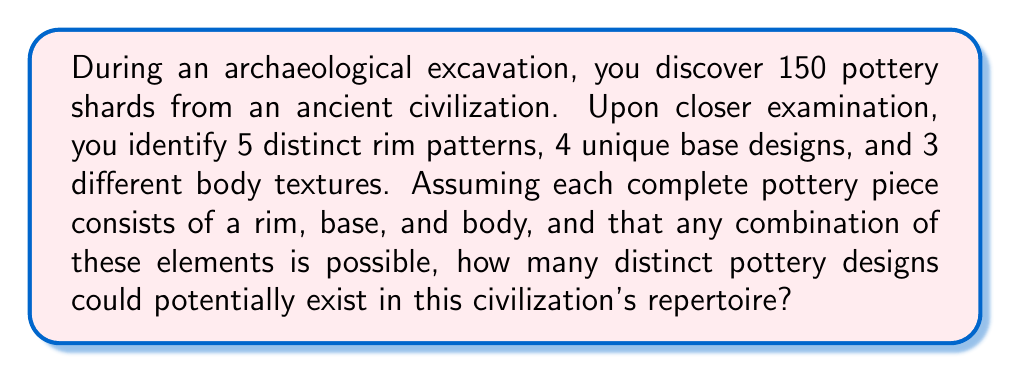Help me with this question. To solve this problem, we'll use the multiplication principle of counting. Here's the step-by-step approach:

1. Identify the independent components:
   - Rim patterns: 5
   - Base designs: 4
   - Body textures: 3

2. Apply the multiplication principle:
   Since each pottery piece consists of one rim pattern, one base design, and one body texture, and any combination is possible, we multiply the number of options for each component.

   $$ \text{Total distinct designs} = \text{Rim patterns} \times \text{Base designs} \times \text{Body textures} $$

3. Plug in the values:
   $$ \text{Total distinct designs} = 5 \times 4 \times 3 $$

4. Calculate the result:
   $$ \text{Total distinct designs} = 60 $$

This means that based on the discovered shards, there could potentially be 60 distinct pottery designs in the ancient civilization's repertoire.
Answer: 60 distinct designs 